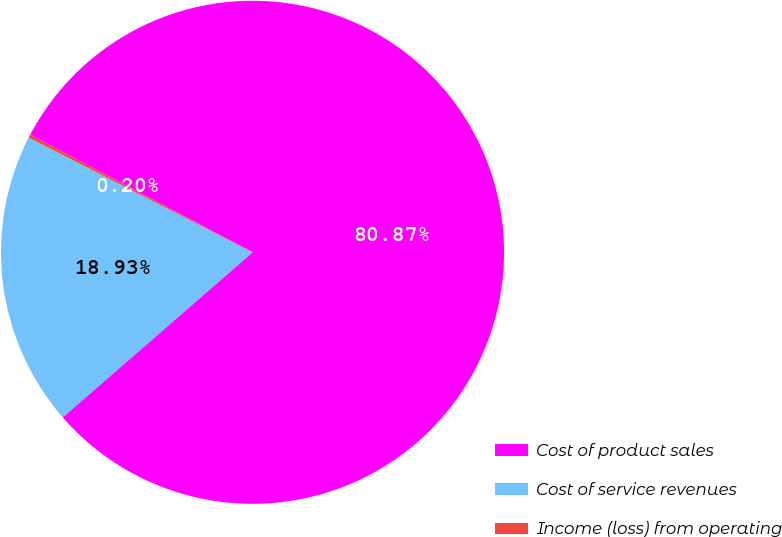Convert chart. <chart><loc_0><loc_0><loc_500><loc_500><pie_chart><fcel>Cost of product sales<fcel>Cost of service revenues<fcel>Income (loss) from operating<nl><fcel>80.87%<fcel>18.93%<fcel>0.2%<nl></chart> 